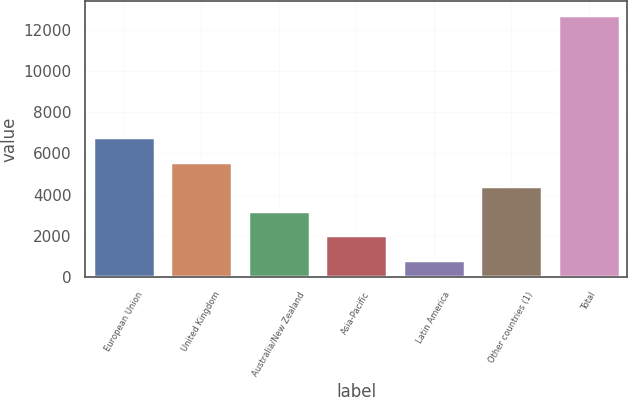Convert chart to OTSL. <chart><loc_0><loc_0><loc_500><loc_500><bar_chart><fcel>European Union<fcel>United Kingdom<fcel>Australia/New Zealand<fcel>Asia-Pacific<fcel>Latin America<fcel>Other countries (1)<fcel>Total<nl><fcel>6784.1<fcel>5596.12<fcel>3220.16<fcel>2032.18<fcel>844.2<fcel>4408.14<fcel>12724<nl></chart> 